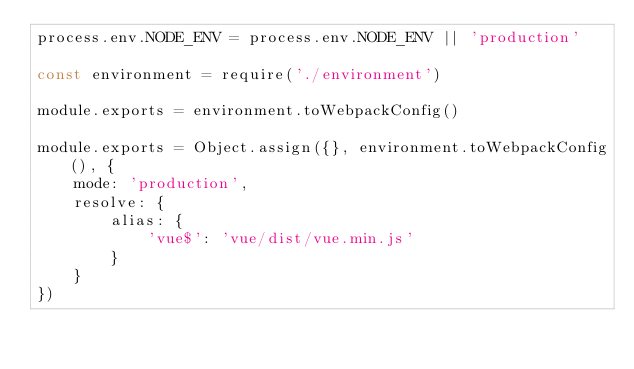Convert code to text. <code><loc_0><loc_0><loc_500><loc_500><_JavaScript_>process.env.NODE_ENV = process.env.NODE_ENV || 'production'

const environment = require('./environment')

module.exports = environment.toWebpackConfig()

module.exports = Object.assign({}, environment.toWebpackConfig(), {
    mode: 'production',
    resolve: {
        alias: {
            'vue$': 'vue/dist/vue.min.js'
        }
    }
})</code> 